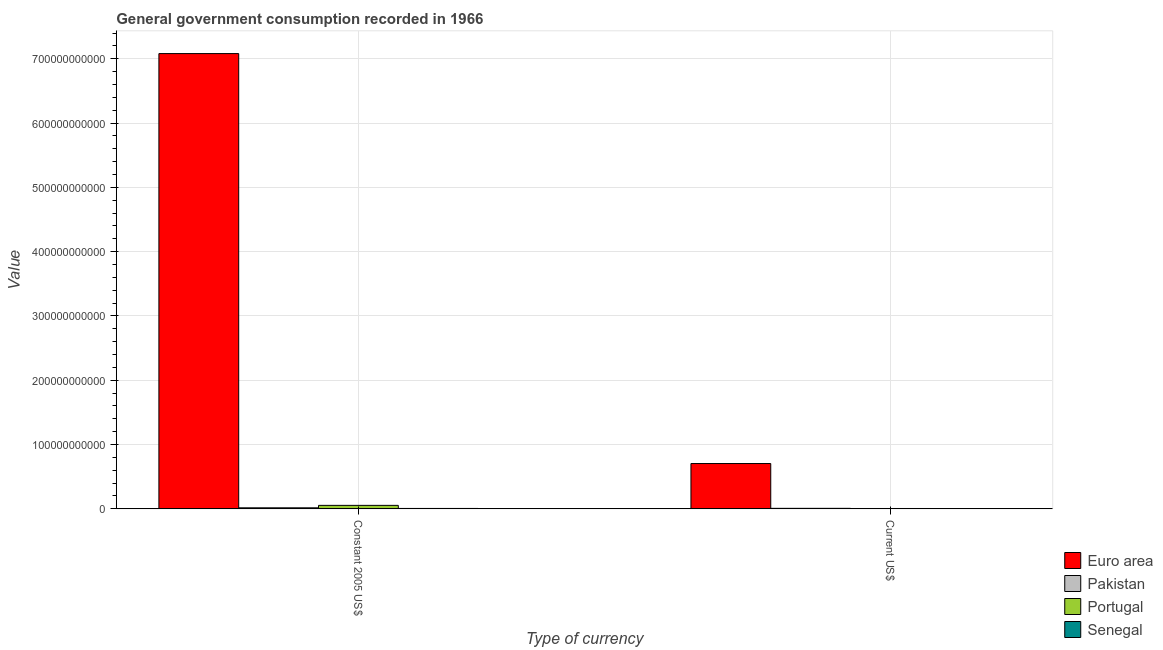How many different coloured bars are there?
Give a very brief answer. 4. How many groups of bars are there?
Provide a short and direct response. 2. Are the number of bars per tick equal to the number of legend labels?
Provide a succinct answer. Yes. What is the label of the 2nd group of bars from the left?
Offer a very short reply. Current US$. What is the value consumed in current us$ in Pakistan?
Your answer should be compact. 7.95e+08. Across all countries, what is the maximum value consumed in current us$?
Keep it short and to the point. 7.05e+1. Across all countries, what is the minimum value consumed in current us$?
Your answer should be compact. 5.59e+07. In which country was the value consumed in constant 2005 us$ minimum?
Make the answer very short. Senegal. What is the total value consumed in current us$ in the graph?
Offer a very short reply. 7.19e+1. What is the difference between the value consumed in constant 2005 us$ in Euro area and that in Portugal?
Ensure brevity in your answer.  7.03e+11. What is the difference between the value consumed in constant 2005 us$ in Pakistan and the value consumed in current us$ in Euro area?
Your answer should be compact. -6.88e+1. What is the average value consumed in current us$ per country?
Your answer should be very brief. 1.80e+1. What is the difference between the value consumed in constant 2005 us$ and value consumed in current us$ in Pakistan?
Ensure brevity in your answer.  8.33e+08. In how many countries, is the value consumed in current us$ greater than 700000000000 ?
Your answer should be compact. 0. What is the ratio of the value consumed in constant 2005 us$ in Senegal to that in Pakistan?
Offer a terse response. 0.38. Is the value consumed in current us$ in Senegal less than that in Portugal?
Provide a short and direct response. Yes. In how many countries, is the value consumed in constant 2005 us$ greater than the average value consumed in constant 2005 us$ taken over all countries?
Make the answer very short. 1. What does the 1st bar from the left in Current US$ represents?
Offer a terse response. Euro area. What is the difference between two consecutive major ticks on the Y-axis?
Your answer should be very brief. 1.00e+11. Are the values on the major ticks of Y-axis written in scientific E-notation?
Offer a very short reply. No. Where does the legend appear in the graph?
Offer a very short reply. Bottom right. How are the legend labels stacked?
Keep it short and to the point. Vertical. What is the title of the graph?
Provide a short and direct response. General government consumption recorded in 1966. What is the label or title of the X-axis?
Offer a terse response. Type of currency. What is the label or title of the Y-axis?
Offer a terse response. Value. What is the Value in Euro area in Constant 2005 US$?
Ensure brevity in your answer.  7.08e+11. What is the Value in Pakistan in Constant 2005 US$?
Make the answer very short. 1.63e+09. What is the Value in Portugal in Constant 2005 US$?
Provide a short and direct response. 5.40e+09. What is the Value of Senegal in Constant 2005 US$?
Offer a terse response. 6.24e+08. What is the Value in Euro area in Current US$?
Offer a very short reply. 7.05e+1. What is the Value of Pakistan in Current US$?
Offer a terse response. 7.95e+08. What is the Value in Portugal in Current US$?
Give a very brief answer. 5.53e+08. What is the Value in Senegal in Current US$?
Make the answer very short. 5.59e+07. Across all Type of currency, what is the maximum Value in Euro area?
Keep it short and to the point. 7.08e+11. Across all Type of currency, what is the maximum Value in Pakistan?
Your answer should be very brief. 1.63e+09. Across all Type of currency, what is the maximum Value in Portugal?
Make the answer very short. 5.40e+09. Across all Type of currency, what is the maximum Value of Senegal?
Your response must be concise. 6.24e+08. Across all Type of currency, what is the minimum Value of Euro area?
Provide a short and direct response. 7.05e+1. Across all Type of currency, what is the minimum Value of Pakistan?
Give a very brief answer. 7.95e+08. Across all Type of currency, what is the minimum Value of Portugal?
Make the answer very short. 5.53e+08. Across all Type of currency, what is the minimum Value of Senegal?
Your answer should be very brief. 5.59e+07. What is the total Value in Euro area in the graph?
Offer a terse response. 7.79e+11. What is the total Value in Pakistan in the graph?
Your response must be concise. 2.42e+09. What is the total Value of Portugal in the graph?
Your answer should be very brief. 5.96e+09. What is the total Value of Senegal in the graph?
Give a very brief answer. 6.80e+08. What is the difference between the Value of Euro area in Constant 2005 US$ and that in Current US$?
Keep it short and to the point. 6.38e+11. What is the difference between the Value of Pakistan in Constant 2005 US$ and that in Current US$?
Provide a short and direct response. 8.33e+08. What is the difference between the Value of Portugal in Constant 2005 US$ and that in Current US$?
Your answer should be very brief. 4.85e+09. What is the difference between the Value of Senegal in Constant 2005 US$ and that in Current US$?
Your answer should be very brief. 5.68e+08. What is the difference between the Value of Euro area in Constant 2005 US$ and the Value of Pakistan in Current US$?
Your response must be concise. 7.07e+11. What is the difference between the Value in Euro area in Constant 2005 US$ and the Value in Portugal in Current US$?
Provide a short and direct response. 7.07e+11. What is the difference between the Value in Euro area in Constant 2005 US$ and the Value in Senegal in Current US$?
Your response must be concise. 7.08e+11. What is the difference between the Value in Pakistan in Constant 2005 US$ and the Value in Portugal in Current US$?
Your answer should be very brief. 1.07e+09. What is the difference between the Value in Pakistan in Constant 2005 US$ and the Value in Senegal in Current US$?
Your answer should be very brief. 1.57e+09. What is the difference between the Value in Portugal in Constant 2005 US$ and the Value in Senegal in Current US$?
Your response must be concise. 5.35e+09. What is the average Value in Euro area per Type of currency?
Make the answer very short. 3.89e+11. What is the average Value in Pakistan per Type of currency?
Your answer should be compact. 1.21e+09. What is the average Value in Portugal per Type of currency?
Keep it short and to the point. 2.98e+09. What is the average Value of Senegal per Type of currency?
Your response must be concise. 3.40e+08. What is the difference between the Value of Euro area and Value of Pakistan in Constant 2005 US$?
Provide a short and direct response. 7.06e+11. What is the difference between the Value in Euro area and Value in Portugal in Constant 2005 US$?
Give a very brief answer. 7.03e+11. What is the difference between the Value of Euro area and Value of Senegal in Constant 2005 US$?
Give a very brief answer. 7.07e+11. What is the difference between the Value of Pakistan and Value of Portugal in Constant 2005 US$?
Offer a very short reply. -3.78e+09. What is the difference between the Value of Pakistan and Value of Senegal in Constant 2005 US$?
Give a very brief answer. 1.00e+09. What is the difference between the Value of Portugal and Value of Senegal in Constant 2005 US$?
Offer a terse response. 4.78e+09. What is the difference between the Value in Euro area and Value in Pakistan in Current US$?
Your answer should be very brief. 6.97e+1. What is the difference between the Value in Euro area and Value in Portugal in Current US$?
Offer a terse response. 6.99e+1. What is the difference between the Value of Euro area and Value of Senegal in Current US$?
Provide a short and direct response. 7.04e+1. What is the difference between the Value of Pakistan and Value of Portugal in Current US$?
Provide a succinct answer. 2.41e+08. What is the difference between the Value of Pakistan and Value of Senegal in Current US$?
Offer a very short reply. 7.39e+08. What is the difference between the Value in Portugal and Value in Senegal in Current US$?
Offer a very short reply. 4.98e+08. What is the ratio of the Value of Euro area in Constant 2005 US$ to that in Current US$?
Offer a terse response. 10.05. What is the ratio of the Value in Pakistan in Constant 2005 US$ to that in Current US$?
Your answer should be very brief. 2.05. What is the ratio of the Value of Portugal in Constant 2005 US$ to that in Current US$?
Ensure brevity in your answer.  9.76. What is the ratio of the Value of Senegal in Constant 2005 US$ to that in Current US$?
Your answer should be very brief. 11.16. What is the difference between the highest and the second highest Value in Euro area?
Ensure brevity in your answer.  6.38e+11. What is the difference between the highest and the second highest Value of Pakistan?
Give a very brief answer. 8.33e+08. What is the difference between the highest and the second highest Value in Portugal?
Your response must be concise. 4.85e+09. What is the difference between the highest and the second highest Value in Senegal?
Ensure brevity in your answer.  5.68e+08. What is the difference between the highest and the lowest Value in Euro area?
Offer a very short reply. 6.38e+11. What is the difference between the highest and the lowest Value of Pakistan?
Your answer should be compact. 8.33e+08. What is the difference between the highest and the lowest Value of Portugal?
Your answer should be very brief. 4.85e+09. What is the difference between the highest and the lowest Value of Senegal?
Provide a succinct answer. 5.68e+08. 